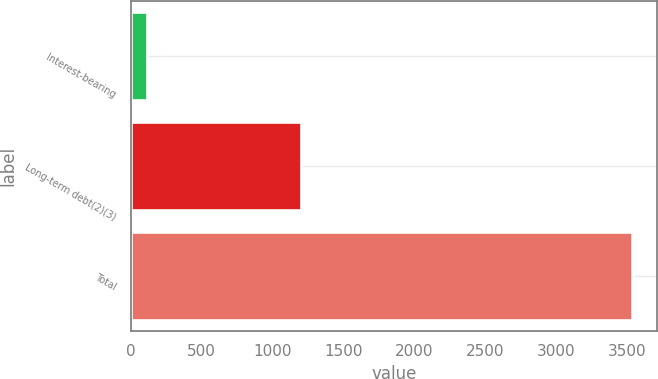Convert chart. <chart><loc_0><loc_0><loc_500><loc_500><bar_chart><fcel>Interest-bearing<fcel>Long-term debt(2)(3)<fcel>Total<nl><fcel>118<fcel>1200<fcel>3529<nl></chart> 